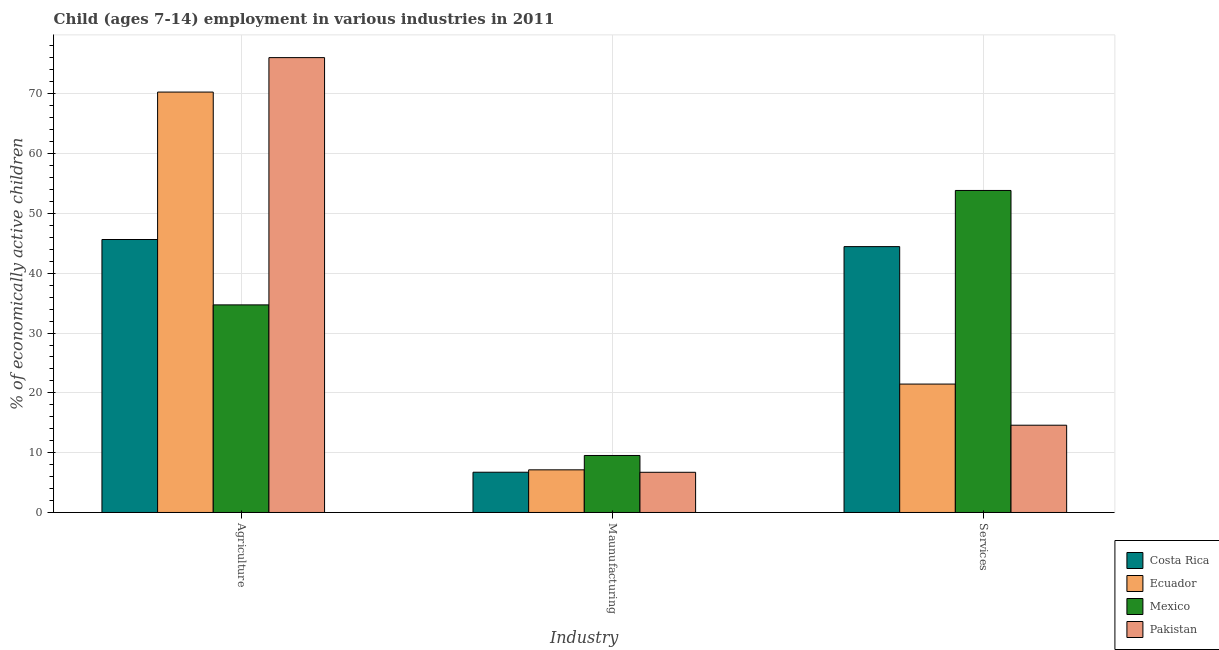How many groups of bars are there?
Your answer should be compact. 3. Are the number of bars per tick equal to the number of legend labels?
Provide a succinct answer. Yes. How many bars are there on the 3rd tick from the left?
Offer a terse response. 4. What is the label of the 2nd group of bars from the left?
Provide a succinct answer. Maunufacturing. What is the percentage of economically active children in agriculture in Ecuador?
Offer a terse response. 70.29. Across all countries, what is the maximum percentage of economically active children in manufacturing?
Offer a very short reply. 9.53. Across all countries, what is the minimum percentage of economically active children in manufacturing?
Your answer should be very brief. 6.72. In which country was the percentage of economically active children in services maximum?
Your answer should be compact. Mexico. In which country was the percentage of economically active children in manufacturing minimum?
Keep it short and to the point. Pakistan. What is the total percentage of economically active children in agriculture in the graph?
Provide a succinct answer. 226.69. What is the difference between the percentage of economically active children in agriculture in Pakistan and that in Ecuador?
Your answer should be very brief. 5.76. What is the difference between the percentage of economically active children in agriculture in Pakistan and the percentage of economically active children in manufacturing in Costa Rica?
Your answer should be compact. 69.32. What is the average percentage of economically active children in agriculture per country?
Keep it short and to the point. 56.67. What is the difference between the percentage of economically active children in manufacturing and percentage of economically active children in services in Ecuador?
Offer a terse response. -14.34. What is the ratio of the percentage of economically active children in manufacturing in Pakistan to that in Costa Rica?
Offer a terse response. 1. What is the difference between the highest and the second highest percentage of economically active children in agriculture?
Your response must be concise. 5.76. What is the difference between the highest and the lowest percentage of economically active children in services?
Ensure brevity in your answer.  39.25. Is the sum of the percentage of economically active children in services in Costa Rica and Pakistan greater than the maximum percentage of economically active children in manufacturing across all countries?
Provide a succinct answer. Yes. What does the 3rd bar from the right in Agriculture represents?
Offer a terse response. Ecuador. Does the graph contain grids?
Your answer should be very brief. Yes. How many legend labels are there?
Your response must be concise. 4. How are the legend labels stacked?
Make the answer very short. Vertical. What is the title of the graph?
Offer a terse response. Child (ages 7-14) employment in various industries in 2011. What is the label or title of the X-axis?
Your response must be concise. Industry. What is the label or title of the Y-axis?
Give a very brief answer. % of economically active children. What is the % of economically active children in Costa Rica in Agriculture?
Your answer should be very brief. 45.64. What is the % of economically active children of Ecuador in Agriculture?
Offer a terse response. 70.29. What is the % of economically active children of Mexico in Agriculture?
Give a very brief answer. 34.71. What is the % of economically active children of Pakistan in Agriculture?
Give a very brief answer. 76.05. What is the % of economically active children of Costa Rica in Maunufacturing?
Make the answer very short. 6.73. What is the % of economically active children of Ecuador in Maunufacturing?
Your answer should be compact. 7.13. What is the % of economically active children of Mexico in Maunufacturing?
Provide a succinct answer. 9.53. What is the % of economically active children in Pakistan in Maunufacturing?
Your answer should be very brief. 6.72. What is the % of economically active children of Costa Rica in Services?
Provide a short and direct response. 44.45. What is the % of economically active children of Ecuador in Services?
Give a very brief answer. 21.47. What is the % of economically active children in Mexico in Services?
Ensure brevity in your answer.  53.84. What is the % of economically active children in Pakistan in Services?
Give a very brief answer. 14.59. Across all Industry, what is the maximum % of economically active children of Costa Rica?
Your answer should be compact. 45.64. Across all Industry, what is the maximum % of economically active children of Ecuador?
Your response must be concise. 70.29. Across all Industry, what is the maximum % of economically active children in Mexico?
Ensure brevity in your answer.  53.84. Across all Industry, what is the maximum % of economically active children in Pakistan?
Make the answer very short. 76.05. Across all Industry, what is the minimum % of economically active children of Costa Rica?
Offer a terse response. 6.73. Across all Industry, what is the minimum % of economically active children of Ecuador?
Offer a terse response. 7.13. Across all Industry, what is the minimum % of economically active children of Mexico?
Provide a short and direct response. 9.53. Across all Industry, what is the minimum % of economically active children in Pakistan?
Make the answer very short. 6.72. What is the total % of economically active children of Costa Rica in the graph?
Your response must be concise. 96.82. What is the total % of economically active children in Ecuador in the graph?
Offer a very short reply. 98.89. What is the total % of economically active children in Mexico in the graph?
Provide a succinct answer. 98.08. What is the total % of economically active children of Pakistan in the graph?
Your answer should be very brief. 97.36. What is the difference between the % of economically active children of Costa Rica in Agriculture and that in Maunufacturing?
Offer a terse response. 38.91. What is the difference between the % of economically active children of Ecuador in Agriculture and that in Maunufacturing?
Keep it short and to the point. 63.16. What is the difference between the % of economically active children in Mexico in Agriculture and that in Maunufacturing?
Offer a very short reply. 25.18. What is the difference between the % of economically active children in Pakistan in Agriculture and that in Maunufacturing?
Your answer should be compact. 69.33. What is the difference between the % of economically active children of Costa Rica in Agriculture and that in Services?
Provide a short and direct response. 1.19. What is the difference between the % of economically active children of Ecuador in Agriculture and that in Services?
Offer a very short reply. 48.82. What is the difference between the % of economically active children in Mexico in Agriculture and that in Services?
Make the answer very short. -19.13. What is the difference between the % of economically active children in Pakistan in Agriculture and that in Services?
Provide a succinct answer. 61.46. What is the difference between the % of economically active children in Costa Rica in Maunufacturing and that in Services?
Provide a succinct answer. -37.72. What is the difference between the % of economically active children of Ecuador in Maunufacturing and that in Services?
Provide a short and direct response. -14.34. What is the difference between the % of economically active children of Mexico in Maunufacturing and that in Services?
Give a very brief answer. -44.31. What is the difference between the % of economically active children in Pakistan in Maunufacturing and that in Services?
Your answer should be very brief. -7.87. What is the difference between the % of economically active children of Costa Rica in Agriculture and the % of economically active children of Ecuador in Maunufacturing?
Your answer should be very brief. 38.51. What is the difference between the % of economically active children of Costa Rica in Agriculture and the % of economically active children of Mexico in Maunufacturing?
Your response must be concise. 36.11. What is the difference between the % of economically active children of Costa Rica in Agriculture and the % of economically active children of Pakistan in Maunufacturing?
Offer a terse response. 38.92. What is the difference between the % of economically active children of Ecuador in Agriculture and the % of economically active children of Mexico in Maunufacturing?
Your response must be concise. 60.76. What is the difference between the % of economically active children of Ecuador in Agriculture and the % of economically active children of Pakistan in Maunufacturing?
Ensure brevity in your answer.  63.57. What is the difference between the % of economically active children of Mexico in Agriculture and the % of economically active children of Pakistan in Maunufacturing?
Ensure brevity in your answer.  27.99. What is the difference between the % of economically active children of Costa Rica in Agriculture and the % of economically active children of Ecuador in Services?
Provide a short and direct response. 24.17. What is the difference between the % of economically active children in Costa Rica in Agriculture and the % of economically active children in Mexico in Services?
Your answer should be compact. -8.2. What is the difference between the % of economically active children of Costa Rica in Agriculture and the % of economically active children of Pakistan in Services?
Keep it short and to the point. 31.05. What is the difference between the % of economically active children of Ecuador in Agriculture and the % of economically active children of Mexico in Services?
Give a very brief answer. 16.45. What is the difference between the % of economically active children in Ecuador in Agriculture and the % of economically active children in Pakistan in Services?
Offer a terse response. 55.7. What is the difference between the % of economically active children in Mexico in Agriculture and the % of economically active children in Pakistan in Services?
Ensure brevity in your answer.  20.12. What is the difference between the % of economically active children in Costa Rica in Maunufacturing and the % of economically active children in Ecuador in Services?
Provide a succinct answer. -14.74. What is the difference between the % of economically active children in Costa Rica in Maunufacturing and the % of economically active children in Mexico in Services?
Your answer should be compact. -47.11. What is the difference between the % of economically active children of Costa Rica in Maunufacturing and the % of economically active children of Pakistan in Services?
Make the answer very short. -7.86. What is the difference between the % of economically active children of Ecuador in Maunufacturing and the % of economically active children of Mexico in Services?
Your response must be concise. -46.71. What is the difference between the % of economically active children in Ecuador in Maunufacturing and the % of economically active children in Pakistan in Services?
Your response must be concise. -7.46. What is the difference between the % of economically active children of Mexico in Maunufacturing and the % of economically active children of Pakistan in Services?
Ensure brevity in your answer.  -5.06. What is the average % of economically active children of Costa Rica per Industry?
Ensure brevity in your answer.  32.27. What is the average % of economically active children in Ecuador per Industry?
Your answer should be compact. 32.96. What is the average % of economically active children of Mexico per Industry?
Ensure brevity in your answer.  32.69. What is the average % of economically active children in Pakistan per Industry?
Keep it short and to the point. 32.45. What is the difference between the % of economically active children in Costa Rica and % of economically active children in Ecuador in Agriculture?
Your response must be concise. -24.65. What is the difference between the % of economically active children in Costa Rica and % of economically active children in Mexico in Agriculture?
Give a very brief answer. 10.93. What is the difference between the % of economically active children of Costa Rica and % of economically active children of Pakistan in Agriculture?
Provide a short and direct response. -30.41. What is the difference between the % of economically active children in Ecuador and % of economically active children in Mexico in Agriculture?
Ensure brevity in your answer.  35.58. What is the difference between the % of economically active children in Ecuador and % of economically active children in Pakistan in Agriculture?
Provide a short and direct response. -5.76. What is the difference between the % of economically active children of Mexico and % of economically active children of Pakistan in Agriculture?
Provide a succinct answer. -41.34. What is the difference between the % of economically active children of Costa Rica and % of economically active children of Ecuador in Maunufacturing?
Your answer should be compact. -0.4. What is the difference between the % of economically active children in Costa Rica and % of economically active children in Mexico in Maunufacturing?
Ensure brevity in your answer.  -2.8. What is the difference between the % of economically active children of Ecuador and % of economically active children of Pakistan in Maunufacturing?
Keep it short and to the point. 0.41. What is the difference between the % of economically active children of Mexico and % of economically active children of Pakistan in Maunufacturing?
Make the answer very short. 2.81. What is the difference between the % of economically active children in Costa Rica and % of economically active children in Ecuador in Services?
Your response must be concise. 22.98. What is the difference between the % of economically active children in Costa Rica and % of economically active children in Mexico in Services?
Your answer should be very brief. -9.39. What is the difference between the % of economically active children in Costa Rica and % of economically active children in Pakistan in Services?
Make the answer very short. 29.86. What is the difference between the % of economically active children in Ecuador and % of economically active children in Mexico in Services?
Make the answer very short. -32.37. What is the difference between the % of economically active children of Ecuador and % of economically active children of Pakistan in Services?
Make the answer very short. 6.88. What is the difference between the % of economically active children of Mexico and % of economically active children of Pakistan in Services?
Keep it short and to the point. 39.25. What is the ratio of the % of economically active children in Costa Rica in Agriculture to that in Maunufacturing?
Your answer should be very brief. 6.78. What is the ratio of the % of economically active children of Ecuador in Agriculture to that in Maunufacturing?
Make the answer very short. 9.86. What is the ratio of the % of economically active children of Mexico in Agriculture to that in Maunufacturing?
Keep it short and to the point. 3.64. What is the ratio of the % of economically active children in Pakistan in Agriculture to that in Maunufacturing?
Provide a short and direct response. 11.32. What is the ratio of the % of economically active children in Costa Rica in Agriculture to that in Services?
Your answer should be very brief. 1.03. What is the ratio of the % of economically active children in Ecuador in Agriculture to that in Services?
Offer a very short reply. 3.27. What is the ratio of the % of economically active children in Mexico in Agriculture to that in Services?
Ensure brevity in your answer.  0.64. What is the ratio of the % of economically active children in Pakistan in Agriculture to that in Services?
Give a very brief answer. 5.21. What is the ratio of the % of economically active children of Costa Rica in Maunufacturing to that in Services?
Offer a terse response. 0.15. What is the ratio of the % of economically active children of Ecuador in Maunufacturing to that in Services?
Offer a terse response. 0.33. What is the ratio of the % of economically active children of Mexico in Maunufacturing to that in Services?
Provide a succinct answer. 0.18. What is the ratio of the % of economically active children in Pakistan in Maunufacturing to that in Services?
Keep it short and to the point. 0.46. What is the difference between the highest and the second highest % of economically active children of Costa Rica?
Offer a terse response. 1.19. What is the difference between the highest and the second highest % of economically active children in Ecuador?
Give a very brief answer. 48.82. What is the difference between the highest and the second highest % of economically active children of Mexico?
Ensure brevity in your answer.  19.13. What is the difference between the highest and the second highest % of economically active children in Pakistan?
Keep it short and to the point. 61.46. What is the difference between the highest and the lowest % of economically active children in Costa Rica?
Your answer should be very brief. 38.91. What is the difference between the highest and the lowest % of economically active children of Ecuador?
Keep it short and to the point. 63.16. What is the difference between the highest and the lowest % of economically active children in Mexico?
Offer a terse response. 44.31. What is the difference between the highest and the lowest % of economically active children of Pakistan?
Offer a terse response. 69.33. 